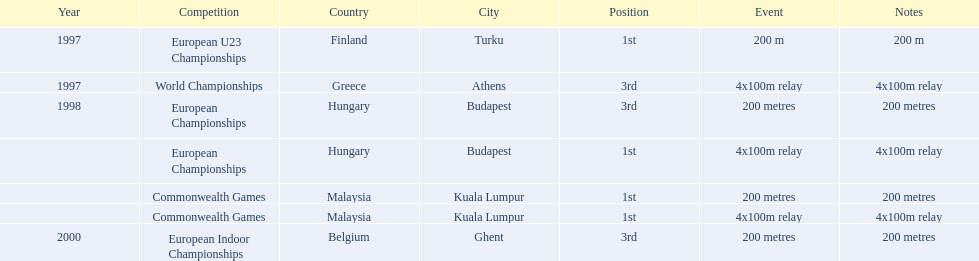List the other competitions besides european u23 championship that came in 1st position? European Championships, Commonwealth Games, Commonwealth Games. 